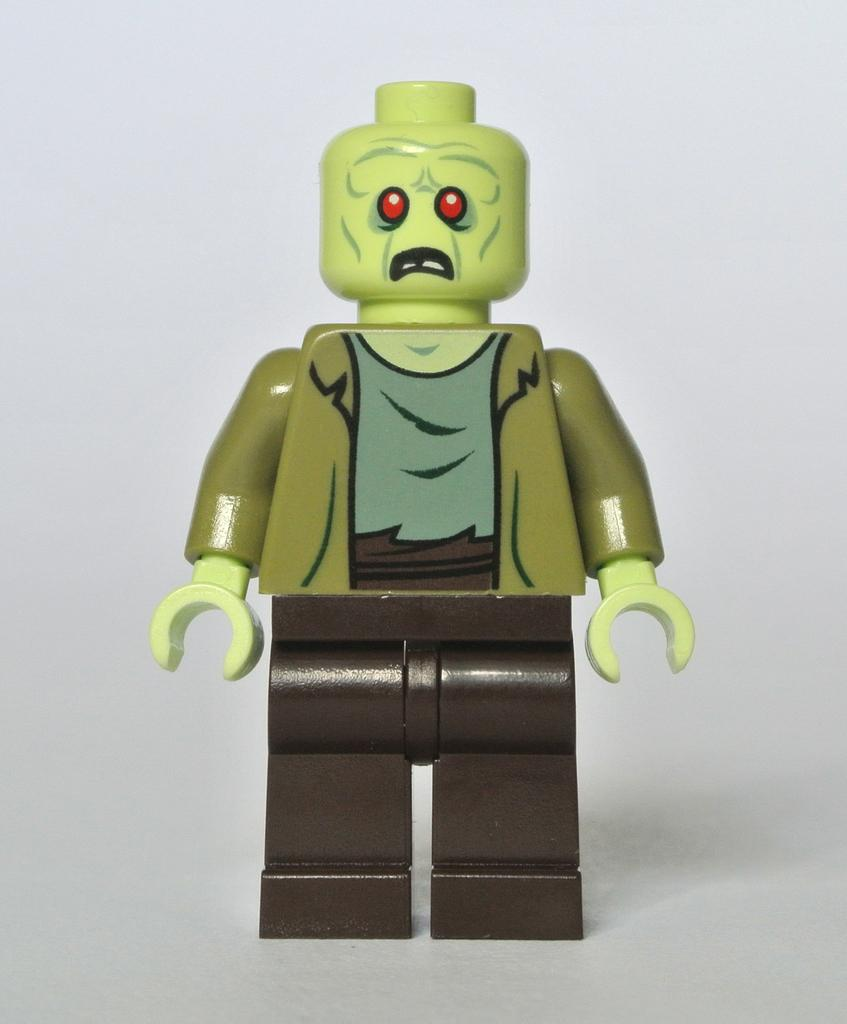What object can be seen in the image? There is a toy in the image. What color is the background of the image? The background of the image is white. Can you provide an example of a smile on the toy's face in the image? There is no toy with a face present in the image, so it is not possible to determine if there is a smile on its face. 